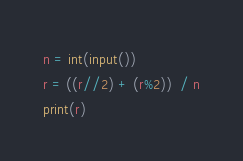<code> <loc_0><loc_0><loc_500><loc_500><_Python_>n = int(input())
r = ((r//2) + (r%2))  / n
print(r)</code> 